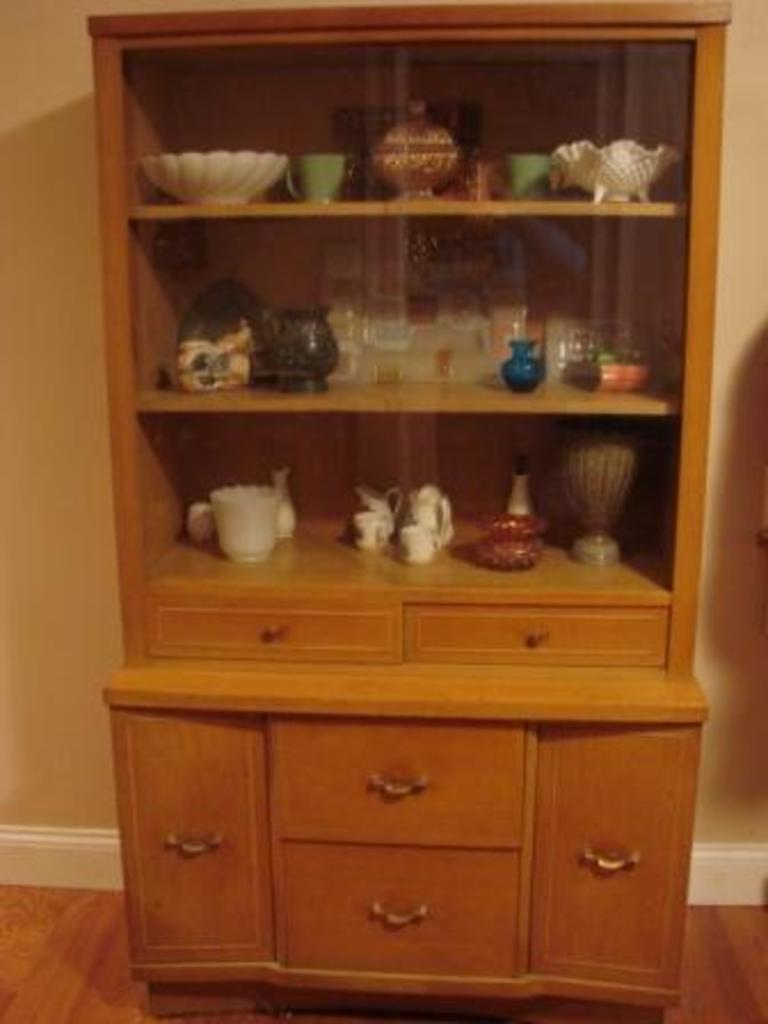What is the main object in the center of the image? There is a wooden cabinet in the center of the image. What items can be found inside the cabinet? The cabinet contains cups, jars, and bowls. Are there any other objects in the cabinet besides cups, jars, and bowls? Yes, there are other objects in the cabinet. What can be seen in the background of the image? There is a wall in the background of the image. What is visible beneath the cabinet? There is a floor visible in the image. How many ducks are sitting on the floor in the image? There are no ducks present in the image; it features a wooden cabinet with various items inside. 